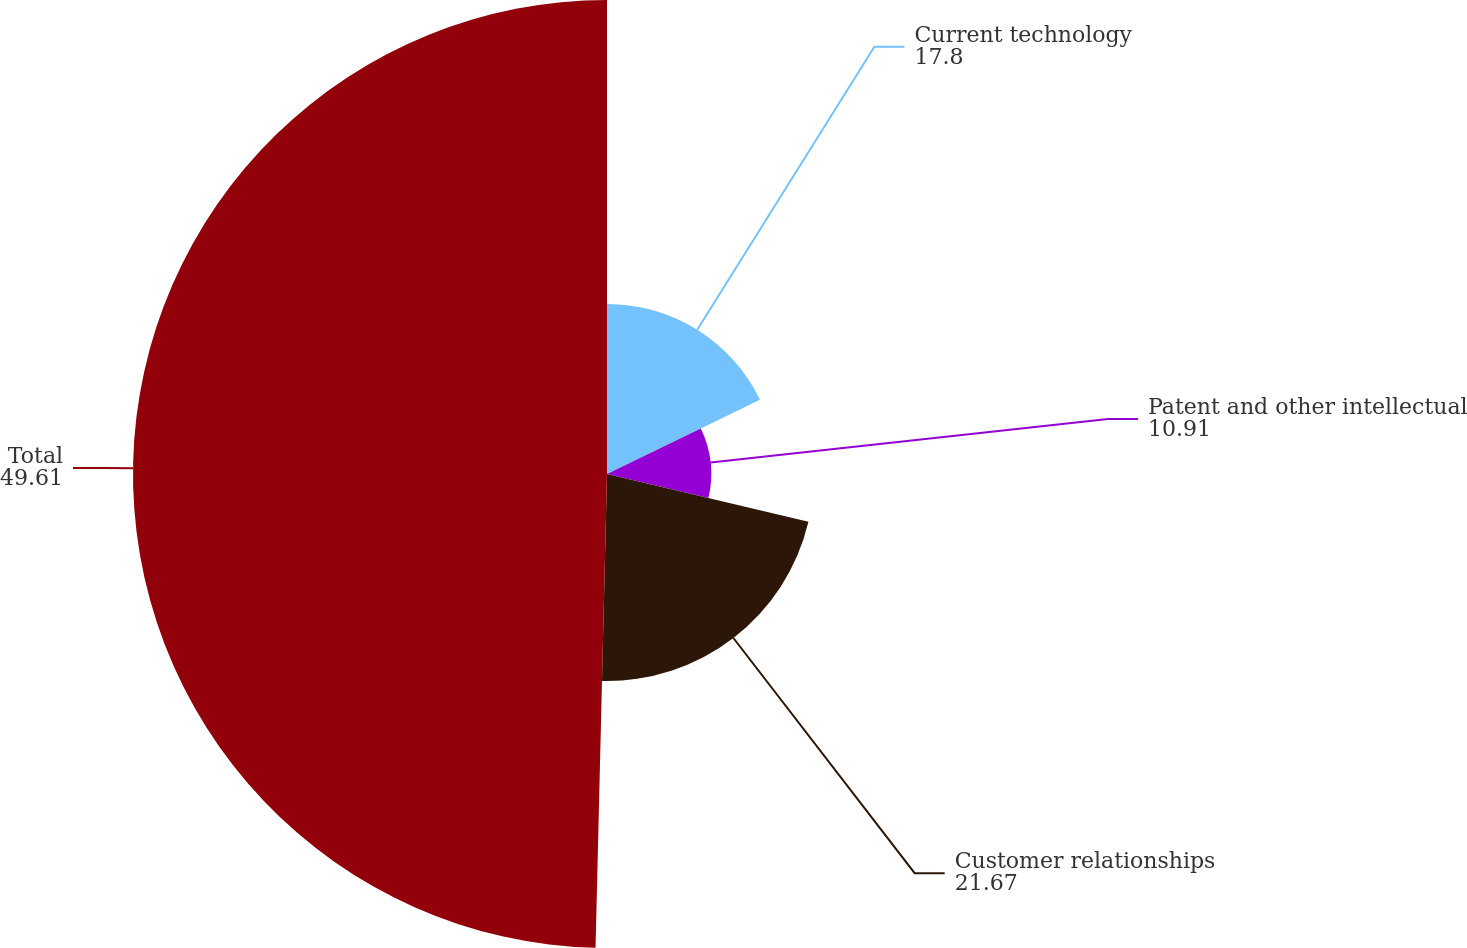<chart> <loc_0><loc_0><loc_500><loc_500><pie_chart><fcel>Current technology<fcel>Patent and other intellectual<fcel>Customer relationships<fcel>Total<nl><fcel>17.8%<fcel>10.91%<fcel>21.67%<fcel>49.61%<nl></chart> 